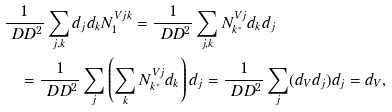<formula> <loc_0><loc_0><loc_500><loc_500>& \frac { 1 } { \ D D ^ { 2 } } \sum _ { j , k } d _ { j } d _ { k } N _ { 1 } ^ { V j k } = \frac { 1 } { \ D D ^ { 2 } } \sum _ { j , k } N _ { k ^ { * } } ^ { V j } d _ { k } d _ { j } \\ & \quad = \frac { 1 } { \ D D ^ { 2 } } \sum _ { j } \left ( \sum _ { k } N _ { k ^ { * } } ^ { V j } d _ { k } \right ) d _ { j } = \frac { 1 } { \ D D ^ { 2 } } \sum _ { j } ( d _ { V } d _ { j } ) d _ { j } = d _ { V } ,</formula> 